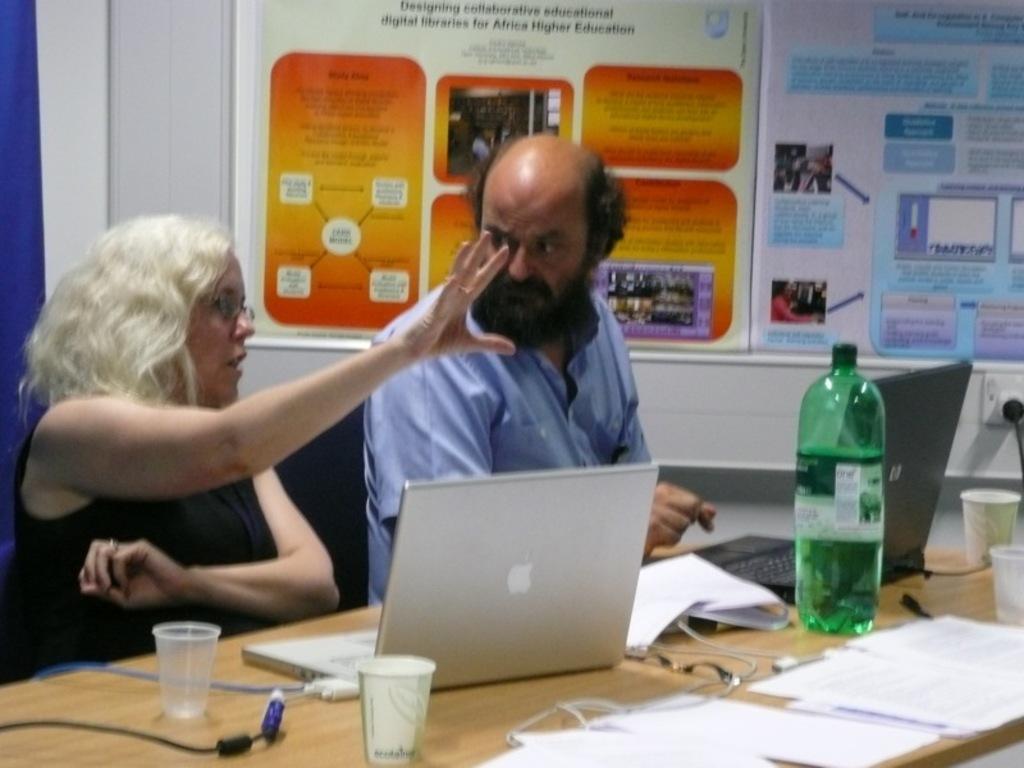Please provide a concise description of this image. On the background we can see boards. here we can see a man and woman sitting on chairs in front of a table and on the table we can see a bottle, glasses, papers, books, watch. This woman is talking. She wore spectacles. This is a socket. 